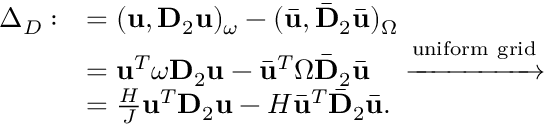Convert formula to latex. <formula><loc_0><loc_0><loc_500><loc_500>\begin{array} { r l } { \Delta _ { D } \colon } & { = ( u , D _ { 2 } u ) _ { \omega } - ( \bar { u } , \bar { D } _ { 2 } \bar { u } ) _ { \Omega } } \\ & { = u ^ { T } \omega D _ { 2 } u - \bar { u } ^ { T } \Omega \bar { D } _ { 2 } \bar { u } \quad \xrightarrow { u n i f o r m g r i d } } \\ & { = \frac { H } { J } u ^ { T } D _ { 2 } u - H \bar { u } ^ { T } \bar { D } _ { 2 } \bar { u } . } \end{array}</formula> 